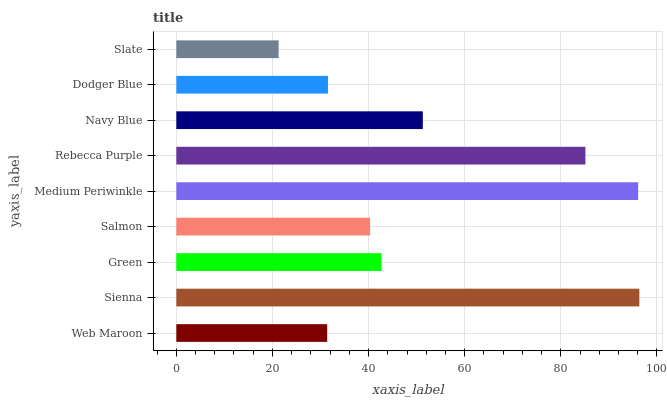Is Slate the minimum?
Answer yes or no. Yes. Is Sienna the maximum?
Answer yes or no. Yes. Is Green the minimum?
Answer yes or no. No. Is Green the maximum?
Answer yes or no. No. Is Sienna greater than Green?
Answer yes or no. Yes. Is Green less than Sienna?
Answer yes or no. Yes. Is Green greater than Sienna?
Answer yes or no. No. Is Sienna less than Green?
Answer yes or no. No. Is Green the high median?
Answer yes or no. Yes. Is Green the low median?
Answer yes or no. Yes. Is Sienna the high median?
Answer yes or no. No. Is Slate the low median?
Answer yes or no. No. 